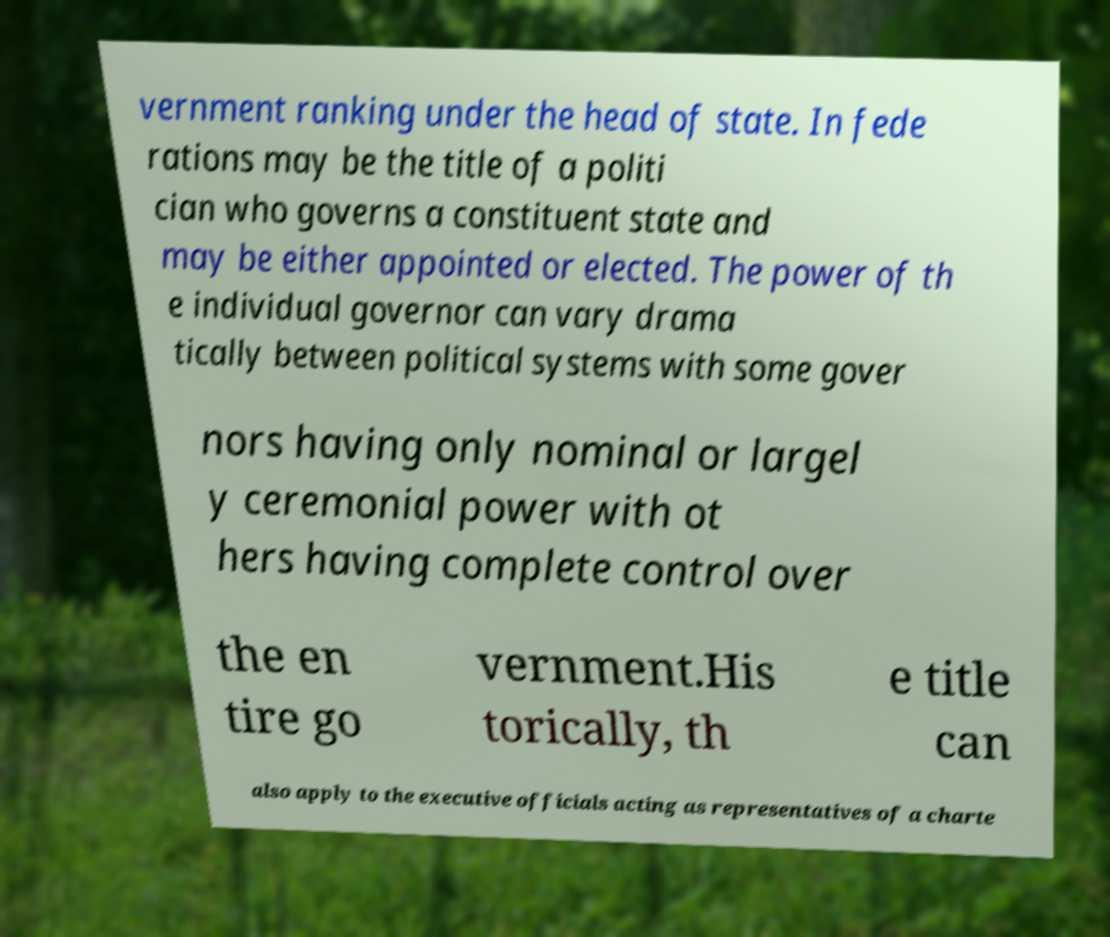Can you read and provide the text displayed in the image?This photo seems to have some interesting text. Can you extract and type it out for me? vernment ranking under the head of state. In fede rations may be the title of a politi cian who governs a constituent state and may be either appointed or elected. The power of th e individual governor can vary drama tically between political systems with some gover nors having only nominal or largel y ceremonial power with ot hers having complete control over the en tire go vernment.His torically, th e title can also apply to the executive officials acting as representatives of a charte 